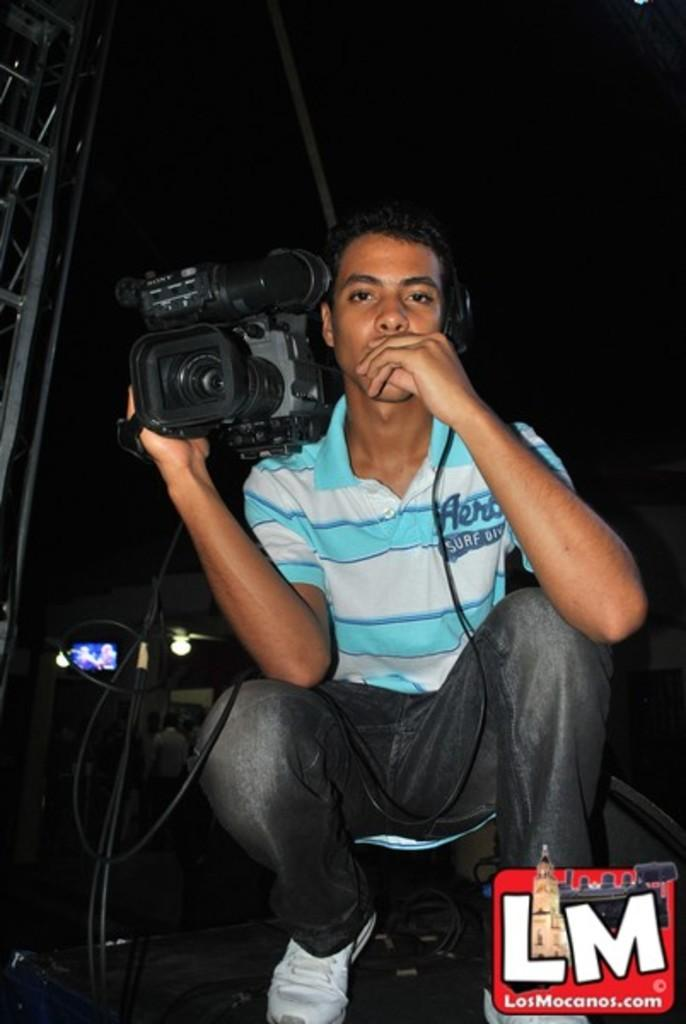What is present in the image? There is a man in the image. What is the man holding in his hand? The man is holding a camera with his hand. What type of mask is the man wearing in the image? The man is not wearing a mask in the image; he is holding a camera. What type of dinner is the man eating in the image? There is no dinner present in the image; the man is holding a camera. 